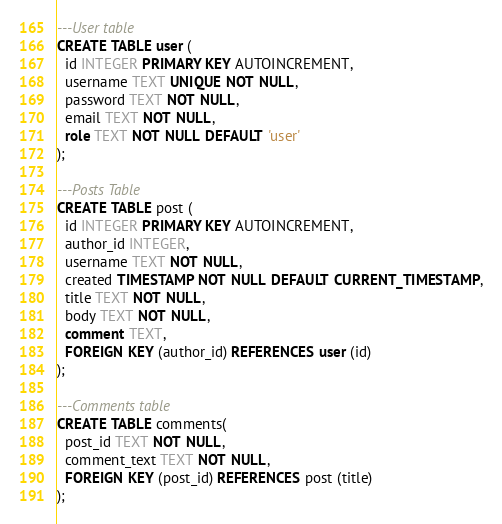Convert code to text. <code><loc_0><loc_0><loc_500><loc_500><_SQL_>
---User table
CREATE TABLE user (
  id INTEGER PRIMARY KEY AUTOINCREMENT,
  username TEXT UNIQUE NOT NULL,
  password TEXT NOT NULL,
  email TEXT NOT NULL,
  role TEXT NOT NULL DEFAULT 'user'
);

---Posts Table
CREATE TABLE post (
  id INTEGER PRIMARY KEY AUTOINCREMENT,
  author_id INTEGER,
  username TEXT NOT NULL,
  created TIMESTAMP NOT NULL DEFAULT CURRENT_TIMESTAMP,
  title TEXT NOT NULL,
  body TEXT NOT NULL,
  comment TEXT,
  FOREIGN KEY (author_id) REFERENCES user (id)
);

---Comments table
CREATE TABLE comments(
  post_id TEXT NOT NULL,
  comment_text TEXT NOT NULL,
  FOREIGN KEY (post_id) REFERENCES post (title)
);
</code> 